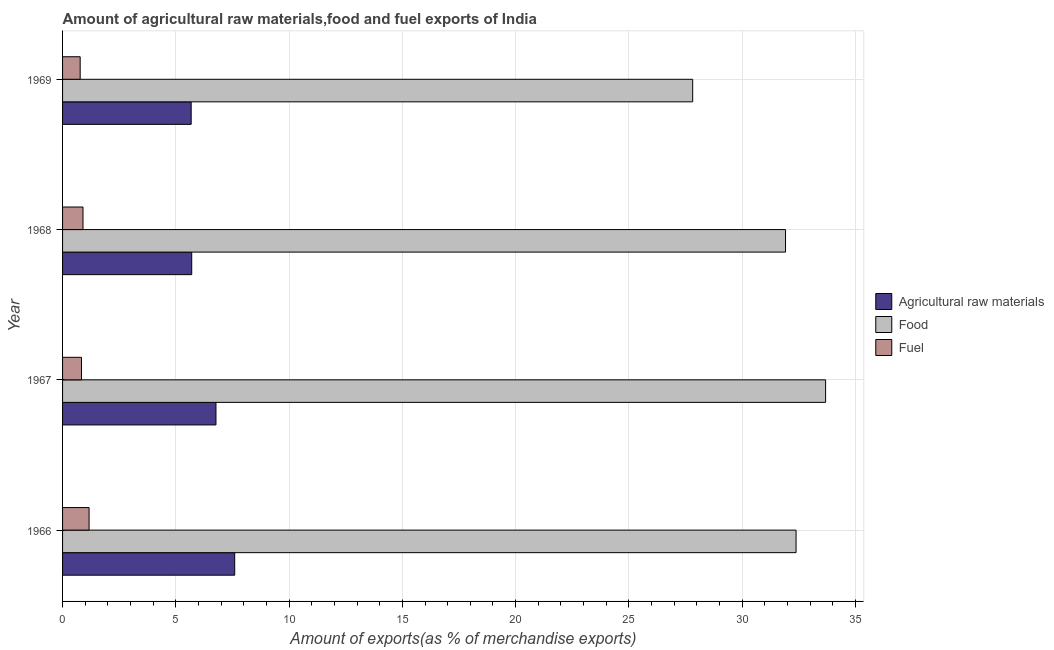How many different coloured bars are there?
Provide a short and direct response. 3. Are the number of bars per tick equal to the number of legend labels?
Your answer should be very brief. Yes. How many bars are there on the 2nd tick from the bottom?
Make the answer very short. 3. What is the label of the 3rd group of bars from the top?
Your answer should be very brief. 1967. What is the percentage of raw materials exports in 1968?
Provide a short and direct response. 5.7. Across all years, what is the maximum percentage of fuel exports?
Offer a very short reply. 1.17. Across all years, what is the minimum percentage of food exports?
Your answer should be very brief. 27.82. In which year was the percentage of raw materials exports maximum?
Offer a terse response. 1966. In which year was the percentage of food exports minimum?
Provide a short and direct response. 1969. What is the total percentage of food exports in the graph?
Offer a terse response. 125.8. What is the difference between the percentage of food exports in 1966 and that in 1968?
Make the answer very short. 0.47. What is the difference between the percentage of food exports in 1969 and the percentage of fuel exports in 1967?
Provide a short and direct response. 26.98. What is the average percentage of food exports per year?
Provide a short and direct response. 31.45. In the year 1969, what is the difference between the percentage of food exports and percentage of raw materials exports?
Your answer should be compact. 22.14. In how many years, is the percentage of raw materials exports greater than 21 %?
Your answer should be very brief. 0. What is the ratio of the percentage of food exports in 1966 to that in 1968?
Make the answer very short. 1.01. Is the percentage of fuel exports in 1966 less than that in 1968?
Offer a very short reply. No. What is the difference between the highest and the second highest percentage of fuel exports?
Make the answer very short. 0.27. What is the difference between the highest and the lowest percentage of fuel exports?
Provide a succinct answer. 0.39. What does the 2nd bar from the top in 1967 represents?
Keep it short and to the point. Food. What does the 1st bar from the bottom in 1966 represents?
Provide a succinct answer. Agricultural raw materials. Does the graph contain grids?
Your answer should be very brief. Yes. How many legend labels are there?
Keep it short and to the point. 3. What is the title of the graph?
Your response must be concise. Amount of agricultural raw materials,food and fuel exports of India. What is the label or title of the X-axis?
Keep it short and to the point. Amount of exports(as % of merchandise exports). What is the label or title of the Y-axis?
Ensure brevity in your answer.  Year. What is the Amount of exports(as % of merchandise exports) of Agricultural raw materials in 1966?
Keep it short and to the point. 7.6. What is the Amount of exports(as % of merchandise exports) in Food in 1966?
Offer a terse response. 32.38. What is the Amount of exports(as % of merchandise exports) in Fuel in 1966?
Offer a terse response. 1.17. What is the Amount of exports(as % of merchandise exports) in Agricultural raw materials in 1967?
Offer a very short reply. 6.77. What is the Amount of exports(as % of merchandise exports) in Food in 1967?
Make the answer very short. 33.68. What is the Amount of exports(as % of merchandise exports) in Fuel in 1967?
Your answer should be very brief. 0.84. What is the Amount of exports(as % of merchandise exports) in Agricultural raw materials in 1968?
Ensure brevity in your answer.  5.7. What is the Amount of exports(as % of merchandise exports) in Food in 1968?
Make the answer very short. 31.92. What is the Amount of exports(as % of merchandise exports) of Fuel in 1968?
Keep it short and to the point. 0.9. What is the Amount of exports(as % of merchandise exports) in Agricultural raw materials in 1969?
Offer a very short reply. 5.68. What is the Amount of exports(as % of merchandise exports) in Food in 1969?
Your answer should be very brief. 27.82. What is the Amount of exports(as % of merchandise exports) of Fuel in 1969?
Give a very brief answer. 0.78. Across all years, what is the maximum Amount of exports(as % of merchandise exports) in Agricultural raw materials?
Provide a succinct answer. 7.6. Across all years, what is the maximum Amount of exports(as % of merchandise exports) of Food?
Ensure brevity in your answer.  33.68. Across all years, what is the maximum Amount of exports(as % of merchandise exports) of Fuel?
Give a very brief answer. 1.17. Across all years, what is the minimum Amount of exports(as % of merchandise exports) of Agricultural raw materials?
Your answer should be compact. 5.68. Across all years, what is the minimum Amount of exports(as % of merchandise exports) of Food?
Your answer should be compact. 27.82. Across all years, what is the minimum Amount of exports(as % of merchandise exports) of Fuel?
Give a very brief answer. 0.78. What is the total Amount of exports(as % of merchandise exports) in Agricultural raw materials in the graph?
Your answer should be very brief. 25.75. What is the total Amount of exports(as % of merchandise exports) of Food in the graph?
Offer a terse response. 125.8. What is the total Amount of exports(as % of merchandise exports) in Fuel in the graph?
Ensure brevity in your answer.  3.69. What is the difference between the Amount of exports(as % of merchandise exports) of Agricultural raw materials in 1966 and that in 1967?
Ensure brevity in your answer.  0.83. What is the difference between the Amount of exports(as % of merchandise exports) of Food in 1966 and that in 1967?
Offer a terse response. -1.3. What is the difference between the Amount of exports(as % of merchandise exports) of Fuel in 1966 and that in 1967?
Provide a short and direct response. 0.34. What is the difference between the Amount of exports(as % of merchandise exports) of Agricultural raw materials in 1966 and that in 1968?
Your answer should be very brief. 1.9. What is the difference between the Amount of exports(as % of merchandise exports) of Food in 1966 and that in 1968?
Give a very brief answer. 0.46. What is the difference between the Amount of exports(as % of merchandise exports) of Fuel in 1966 and that in 1968?
Make the answer very short. 0.27. What is the difference between the Amount of exports(as % of merchandise exports) of Agricultural raw materials in 1966 and that in 1969?
Give a very brief answer. 1.92. What is the difference between the Amount of exports(as % of merchandise exports) of Food in 1966 and that in 1969?
Make the answer very short. 4.56. What is the difference between the Amount of exports(as % of merchandise exports) of Fuel in 1966 and that in 1969?
Provide a short and direct response. 0.39. What is the difference between the Amount of exports(as % of merchandise exports) in Agricultural raw materials in 1967 and that in 1968?
Make the answer very short. 1.07. What is the difference between the Amount of exports(as % of merchandise exports) in Food in 1967 and that in 1968?
Your answer should be compact. 1.77. What is the difference between the Amount of exports(as % of merchandise exports) of Fuel in 1967 and that in 1968?
Give a very brief answer. -0.07. What is the difference between the Amount of exports(as % of merchandise exports) of Agricultural raw materials in 1967 and that in 1969?
Provide a succinct answer. 1.09. What is the difference between the Amount of exports(as % of merchandise exports) of Food in 1967 and that in 1969?
Your answer should be compact. 5.87. What is the difference between the Amount of exports(as % of merchandise exports) in Fuel in 1967 and that in 1969?
Keep it short and to the point. 0.06. What is the difference between the Amount of exports(as % of merchandise exports) in Agricultural raw materials in 1968 and that in 1969?
Make the answer very short. 0.02. What is the difference between the Amount of exports(as % of merchandise exports) of Food in 1968 and that in 1969?
Offer a very short reply. 4.1. What is the difference between the Amount of exports(as % of merchandise exports) in Fuel in 1968 and that in 1969?
Your response must be concise. 0.13. What is the difference between the Amount of exports(as % of merchandise exports) of Agricultural raw materials in 1966 and the Amount of exports(as % of merchandise exports) of Food in 1967?
Provide a short and direct response. -26.09. What is the difference between the Amount of exports(as % of merchandise exports) in Agricultural raw materials in 1966 and the Amount of exports(as % of merchandise exports) in Fuel in 1967?
Ensure brevity in your answer.  6.76. What is the difference between the Amount of exports(as % of merchandise exports) in Food in 1966 and the Amount of exports(as % of merchandise exports) in Fuel in 1967?
Give a very brief answer. 31.55. What is the difference between the Amount of exports(as % of merchandise exports) in Agricultural raw materials in 1966 and the Amount of exports(as % of merchandise exports) in Food in 1968?
Provide a succinct answer. -24.32. What is the difference between the Amount of exports(as % of merchandise exports) in Agricultural raw materials in 1966 and the Amount of exports(as % of merchandise exports) in Fuel in 1968?
Your answer should be very brief. 6.7. What is the difference between the Amount of exports(as % of merchandise exports) of Food in 1966 and the Amount of exports(as % of merchandise exports) of Fuel in 1968?
Your answer should be compact. 31.48. What is the difference between the Amount of exports(as % of merchandise exports) in Agricultural raw materials in 1966 and the Amount of exports(as % of merchandise exports) in Food in 1969?
Give a very brief answer. -20.22. What is the difference between the Amount of exports(as % of merchandise exports) in Agricultural raw materials in 1966 and the Amount of exports(as % of merchandise exports) in Fuel in 1969?
Provide a short and direct response. 6.82. What is the difference between the Amount of exports(as % of merchandise exports) of Food in 1966 and the Amount of exports(as % of merchandise exports) of Fuel in 1969?
Provide a short and direct response. 31.6. What is the difference between the Amount of exports(as % of merchandise exports) in Agricultural raw materials in 1967 and the Amount of exports(as % of merchandise exports) in Food in 1968?
Give a very brief answer. -25.14. What is the difference between the Amount of exports(as % of merchandise exports) of Agricultural raw materials in 1967 and the Amount of exports(as % of merchandise exports) of Fuel in 1968?
Your response must be concise. 5.87. What is the difference between the Amount of exports(as % of merchandise exports) of Food in 1967 and the Amount of exports(as % of merchandise exports) of Fuel in 1968?
Give a very brief answer. 32.78. What is the difference between the Amount of exports(as % of merchandise exports) in Agricultural raw materials in 1967 and the Amount of exports(as % of merchandise exports) in Food in 1969?
Your answer should be very brief. -21.05. What is the difference between the Amount of exports(as % of merchandise exports) of Agricultural raw materials in 1967 and the Amount of exports(as % of merchandise exports) of Fuel in 1969?
Your response must be concise. 5.99. What is the difference between the Amount of exports(as % of merchandise exports) in Food in 1967 and the Amount of exports(as % of merchandise exports) in Fuel in 1969?
Give a very brief answer. 32.91. What is the difference between the Amount of exports(as % of merchandise exports) in Agricultural raw materials in 1968 and the Amount of exports(as % of merchandise exports) in Food in 1969?
Provide a succinct answer. -22.12. What is the difference between the Amount of exports(as % of merchandise exports) of Agricultural raw materials in 1968 and the Amount of exports(as % of merchandise exports) of Fuel in 1969?
Your answer should be very brief. 4.92. What is the difference between the Amount of exports(as % of merchandise exports) of Food in 1968 and the Amount of exports(as % of merchandise exports) of Fuel in 1969?
Offer a very short reply. 31.14. What is the average Amount of exports(as % of merchandise exports) of Agricultural raw materials per year?
Give a very brief answer. 6.44. What is the average Amount of exports(as % of merchandise exports) in Food per year?
Your response must be concise. 31.45. What is the average Amount of exports(as % of merchandise exports) of Fuel per year?
Provide a short and direct response. 0.92. In the year 1966, what is the difference between the Amount of exports(as % of merchandise exports) in Agricultural raw materials and Amount of exports(as % of merchandise exports) in Food?
Provide a succinct answer. -24.78. In the year 1966, what is the difference between the Amount of exports(as % of merchandise exports) of Agricultural raw materials and Amount of exports(as % of merchandise exports) of Fuel?
Give a very brief answer. 6.43. In the year 1966, what is the difference between the Amount of exports(as % of merchandise exports) of Food and Amount of exports(as % of merchandise exports) of Fuel?
Make the answer very short. 31.21. In the year 1967, what is the difference between the Amount of exports(as % of merchandise exports) in Agricultural raw materials and Amount of exports(as % of merchandise exports) in Food?
Provide a succinct answer. -26.91. In the year 1967, what is the difference between the Amount of exports(as % of merchandise exports) in Agricultural raw materials and Amount of exports(as % of merchandise exports) in Fuel?
Keep it short and to the point. 5.94. In the year 1967, what is the difference between the Amount of exports(as % of merchandise exports) in Food and Amount of exports(as % of merchandise exports) in Fuel?
Your answer should be compact. 32.85. In the year 1968, what is the difference between the Amount of exports(as % of merchandise exports) in Agricultural raw materials and Amount of exports(as % of merchandise exports) in Food?
Give a very brief answer. -26.21. In the year 1968, what is the difference between the Amount of exports(as % of merchandise exports) of Agricultural raw materials and Amount of exports(as % of merchandise exports) of Fuel?
Offer a terse response. 4.8. In the year 1968, what is the difference between the Amount of exports(as % of merchandise exports) of Food and Amount of exports(as % of merchandise exports) of Fuel?
Keep it short and to the point. 31.01. In the year 1969, what is the difference between the Amount of exports(as % of merchandise exports) in Agricultural raw materials and Amount of exports(as % of merchandise exports) in Food?
Your answer should be compact. -22.14. In the year 1969, what is the difference between the Amount of exports(as % of merchandise exports) of Food and Amount of exports(as % of merchandise exports) of Fuel?
Offer a very short reply. 27.04. What is the ratio of the Amount of exports(as % of merchandise exports) in Agricultural raw materials in 1966 to that in 1967?
Provide a short and direct response. 1.12. What is the ratio of the Amount of exports(as % of merchandise exports) in Food in 1966 to that in 1967?
Provide a short and direct response. 0.96. What is the ratio of the Amount of exports(as % of merchandise exports) in Fuel in 1966 to that in 1967?
Offer a very short reply. 1.4. What is the ratio of the Amount of exports(as % of merchandise exports) in Agricultural raw materials in 1966 to that in 1968?
Give a very brief answer. 1.33. What is the ratio of the Amount of exports(as % of merchandise exports) in Food in 1966 to that in 1968?
Provide a short and direct response. 1.01. What is the ratio of the Amount of exports(as % of merchandise exports) of Fuel in 1966 to that in 1968?
Ensure brevity in your answer.  1.3. What is the ratio of the Amount of exports(as % of merchandise exports) of Agricultural raw materials in 1966 to that in 1969?
Your response must be concise. 1.34. What is the ratio of the Amount of exports(as % of merchandise exports) in Food in 1966 to that in 1969?
Provide a succinct answer. 1.16. What is the ratio of the Amount of exports(as % of merchandise exports) in Fuel in 1966 to that in 1969?
Give a very brief answer. 1.51. What is the ratio of the Amount of exports(as % of merchandise exports) in Agricultural raw materials in 1967 to that in 1968?
Your response must be concise. 1.19. What is the ratio of the Amount of exports(as % of merchandise exports) in Food in 1967 to that in 1968?
Make the answer very short. 1.06. What is the ratio of the Amount of exports(as % of merchandise exports) of Fuel in 1967 to that in 1968?
Make the answer very short. 0.93. What is the ratio of the Amount of exports(as % of merchandise exports) of Agricultural raw materials in 1967 to that in 1969?
Keep it short and to the point. 1.19. What is the ratio of the Amount of exports(as % of merchandise exports) in Food in 1967 to that in 1969?
Your answer should be very brief. 1.21. What is the ratio of the Amount of exports(as % of merchandise exports) of Fuel in 1967 to that in 1969?
Your answer should be very brief. 1.07. What is the ratio of the Amount of exports(as % of merchandise exports) in Food in 1968 to that in 1969?
Give a very brief answer. 1.15. What is the ratio of the Amount of exports(as % of merchandise exports) in Fuel in 1968 to that in 1969?
Make the answer very short. 1.16. What is the difference between the highest and the second highest Amount of exports(as % of merchandise exports) of Agricultural raw materials?
Offer a very short reply. 0.83. What is the difference between the highest and the second highest Amount of exports(as % of merchandise exports) of Food?
Keep it short and to the point. 1.3. What is the difference between the highest and the second highest Amount of exports(as % of merchandise exports) of Fuel?
Provide a short and direct response. 0.27. What is the difference between the highest and the lowest Amount of exports(as % of merchandise exports) of Agricultural raw materials?
Your answer should be compact. 1.92. What is the difference between the highest and the lowest Amount of exports(as % of merchandise exports) in Food?
Give a very brief answer. 5.87. What is the difference between the highest and the lowest Amount of exports(as % of merchandise exports) of Fuel?
Your response must be concise. 0.39. 